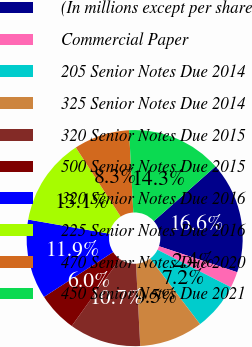Convert chart. <chart><loc_0><loc_0><loc_500><loc_500><pie_chart><fcel>(In millions except per share<fcel>Commercial Paper<fcel>205 Senior Notes Due 2014<fcel>325 Senior Notes Due 2014<fcel>320 Senior Notes Due 2015<fcel>500 Senior Notes Due 2015<fcel>320 Senior Notes Due 2016<fcel>225 Senior Notes Due 2016<fcel>470 Senior Notes Due 2020<fcel>450 Senior Notes Due 2021<nl><fcel>16.65%<fcel>2.4%<fcel>7.15%<fcel>9.52%<fcel>10.71%<fcel>5.96%<fcel>11.9%<fcel>13.09%<fcel>8.34%<fcel>14.28%<nl></chart> 